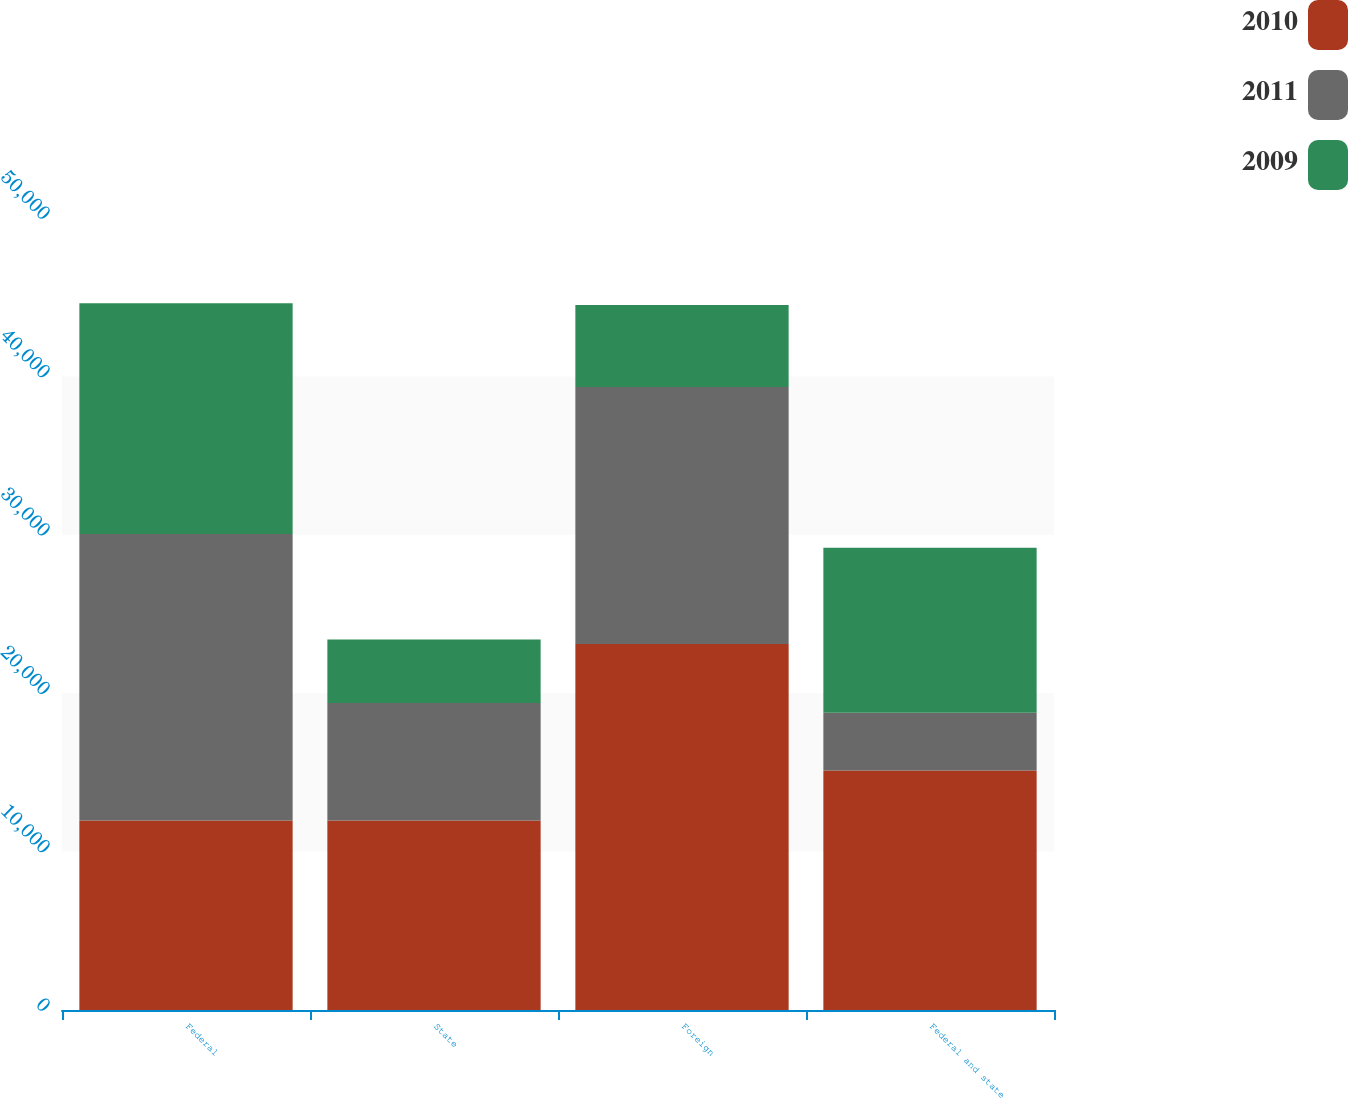Convert chart to OTSL. <chart><loc_0><loc_0><loc_500><loc_500><stacked_bar_chart><ecel><fcel>Federal<fcel>State<fcel>Foreign<fcel>Federal and state<nl><fcel>2010<fcel>11969<fcel>11969<fcel>23101<fcel>15117<nl><fcel>2011<fcel>18085<fcel>7412<fcel>16232<fcel>3654<nl><fcel>2009<fcel>14571<fcel>4008<fcel>5169<fcel>10412<nl></chart> 